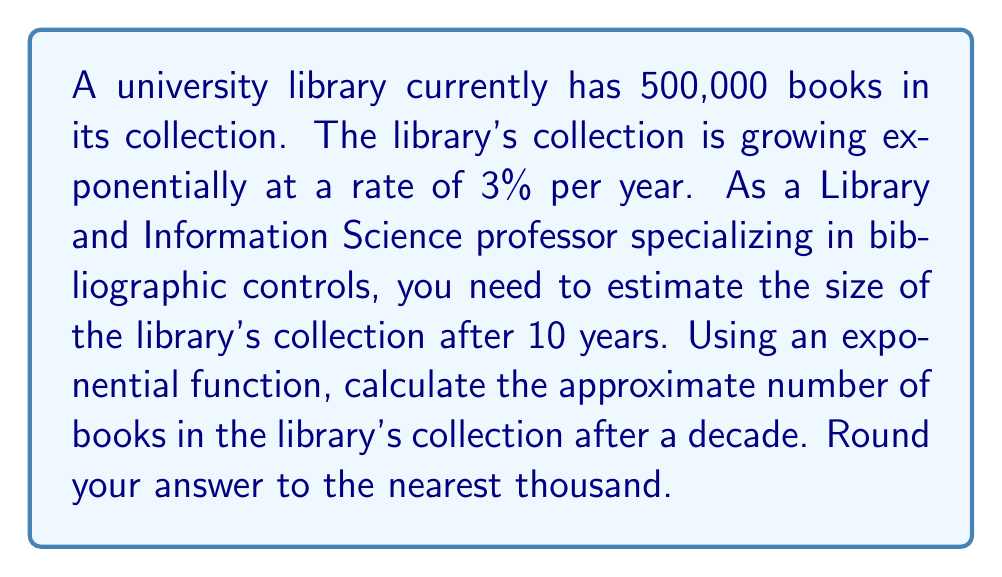Show me your answer to this math problem. To solve this problem, we'll use the exponential growth formula:

$$A = P(1 + r)^t$$

Where:
$A$ = Final amount
$P$ = Initial principal balance
$r$ = Annual growth rate (as a decimal)
$t$ = Time in years

Given:
$P = 500,000$ (initial number of books)
$r = 0.03$ (3% growth rate)
$t = 10$ years

Let's substitute these values into the formula:

$$A = 500,000(1 + 0.03)^{10}$$

Now, let's calculate:

1. First, compute $(1 + 0.03)^{10}$:
   $$(1.03)^{10} \approx 1.3439$$

2. Multiply this by the initial number of books:
   $$500,000 \times 1.3439 \approx 671,958.23$$

3. Round to the nearest thousand:
   $$671,958 \approx 672,000$$

Therefore, after 10 years, the library's collection will have approximately 672,000 books.
Answer: 672,000 books 